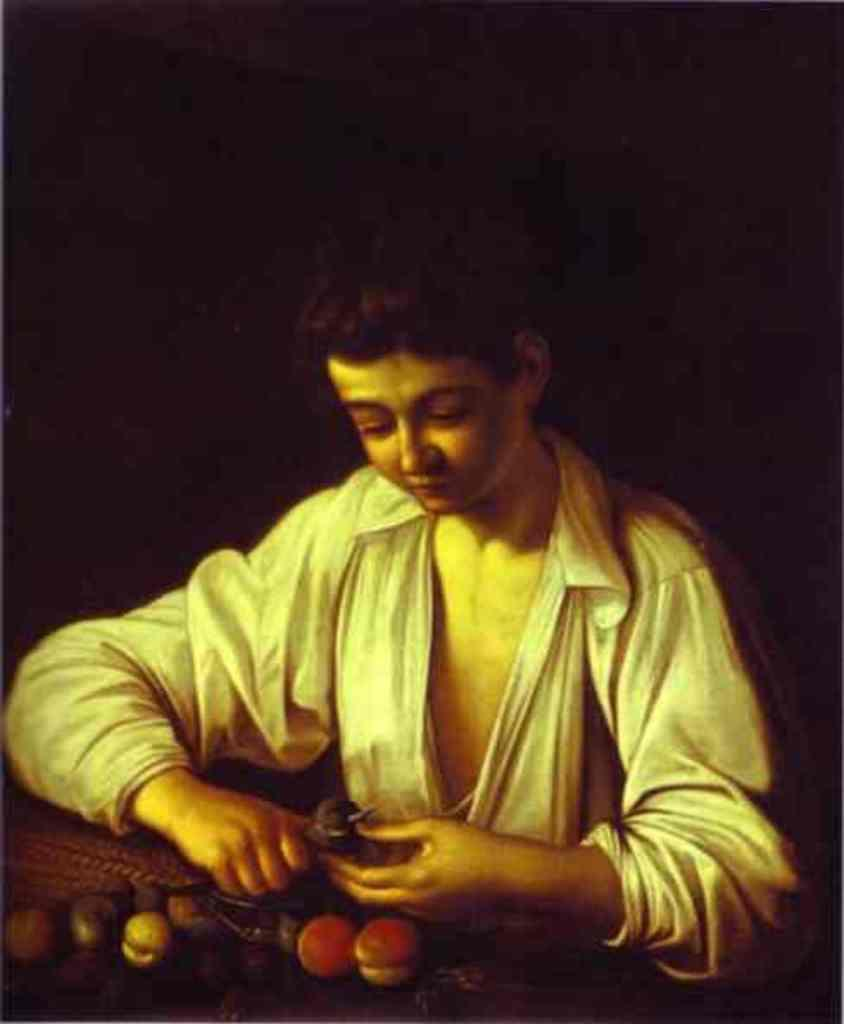What is the main subject of the image? There is a painting in the image. Can you describe the background of the image? The background of the image is dark. What type of sign can be seen in the painting? There is no sign present in the painting; the image only shows a painting with a dark background. 